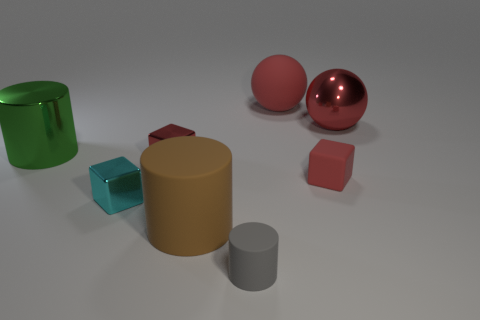What number of other things are the same size as the brown cylinder?
Provide a short and direct response. 3. There is a shiny object that is behind the big green metallic thing; is it the same color as the small rubber cube?
Provide a short and direct response. Yes. There is a gray rubber object; what shape is it?
Your answer should be compact. Cylinder. Is the material of the big cylinder to the right of the cyan cube the same as the big cylinder behind the large brown object?
Keep it short and to the point. No. How many rubber objects have the same color as the rubber ball?
Your answer should be compact. 1. There is a metallic object that is to the right of the cyan object and to the left of the red matte sphere; what shape is it?
Your answer should be very brief. Cube. What is the color of the metal object that is behind the tiny cyan metallic thing and in front of the large green metallic cylinder?
Your answer should be compact. Red. Is the number of red matte things behind the large brown object greater than the number of small cylinders that are to the left of the cyan thing?
Keep it short and to the point. Yes. The large metallic thing right of the large brown cylinder is what color?
Ensure brevity in your answer.  Red. Do the large metal thing that is left of the cyan thing and the matte thing that is to the left of the small cylinder have the same shape?
Offer a very short reply. Yes. 